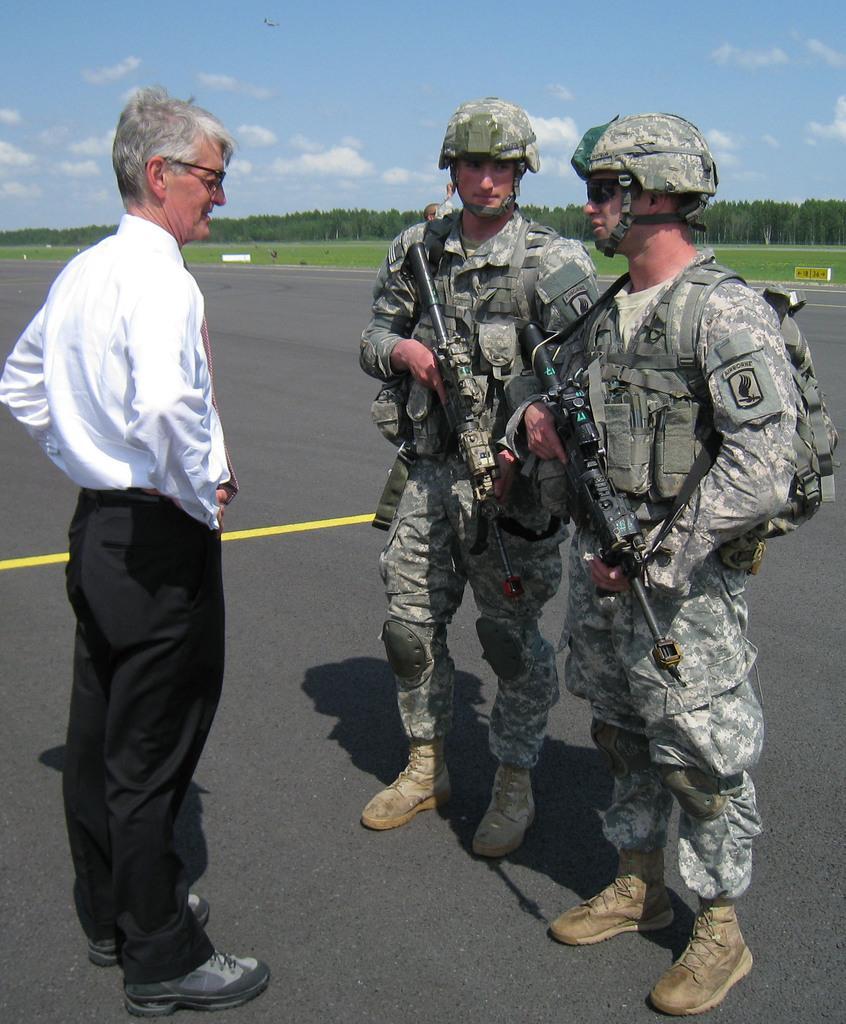Could you give a brief overview of what you see in this image? In this image I can see few people standing on the road. l I can see one person with white and black color dress and two people with the military uniforms. In the back there are trees, clouds and the blue sky. 